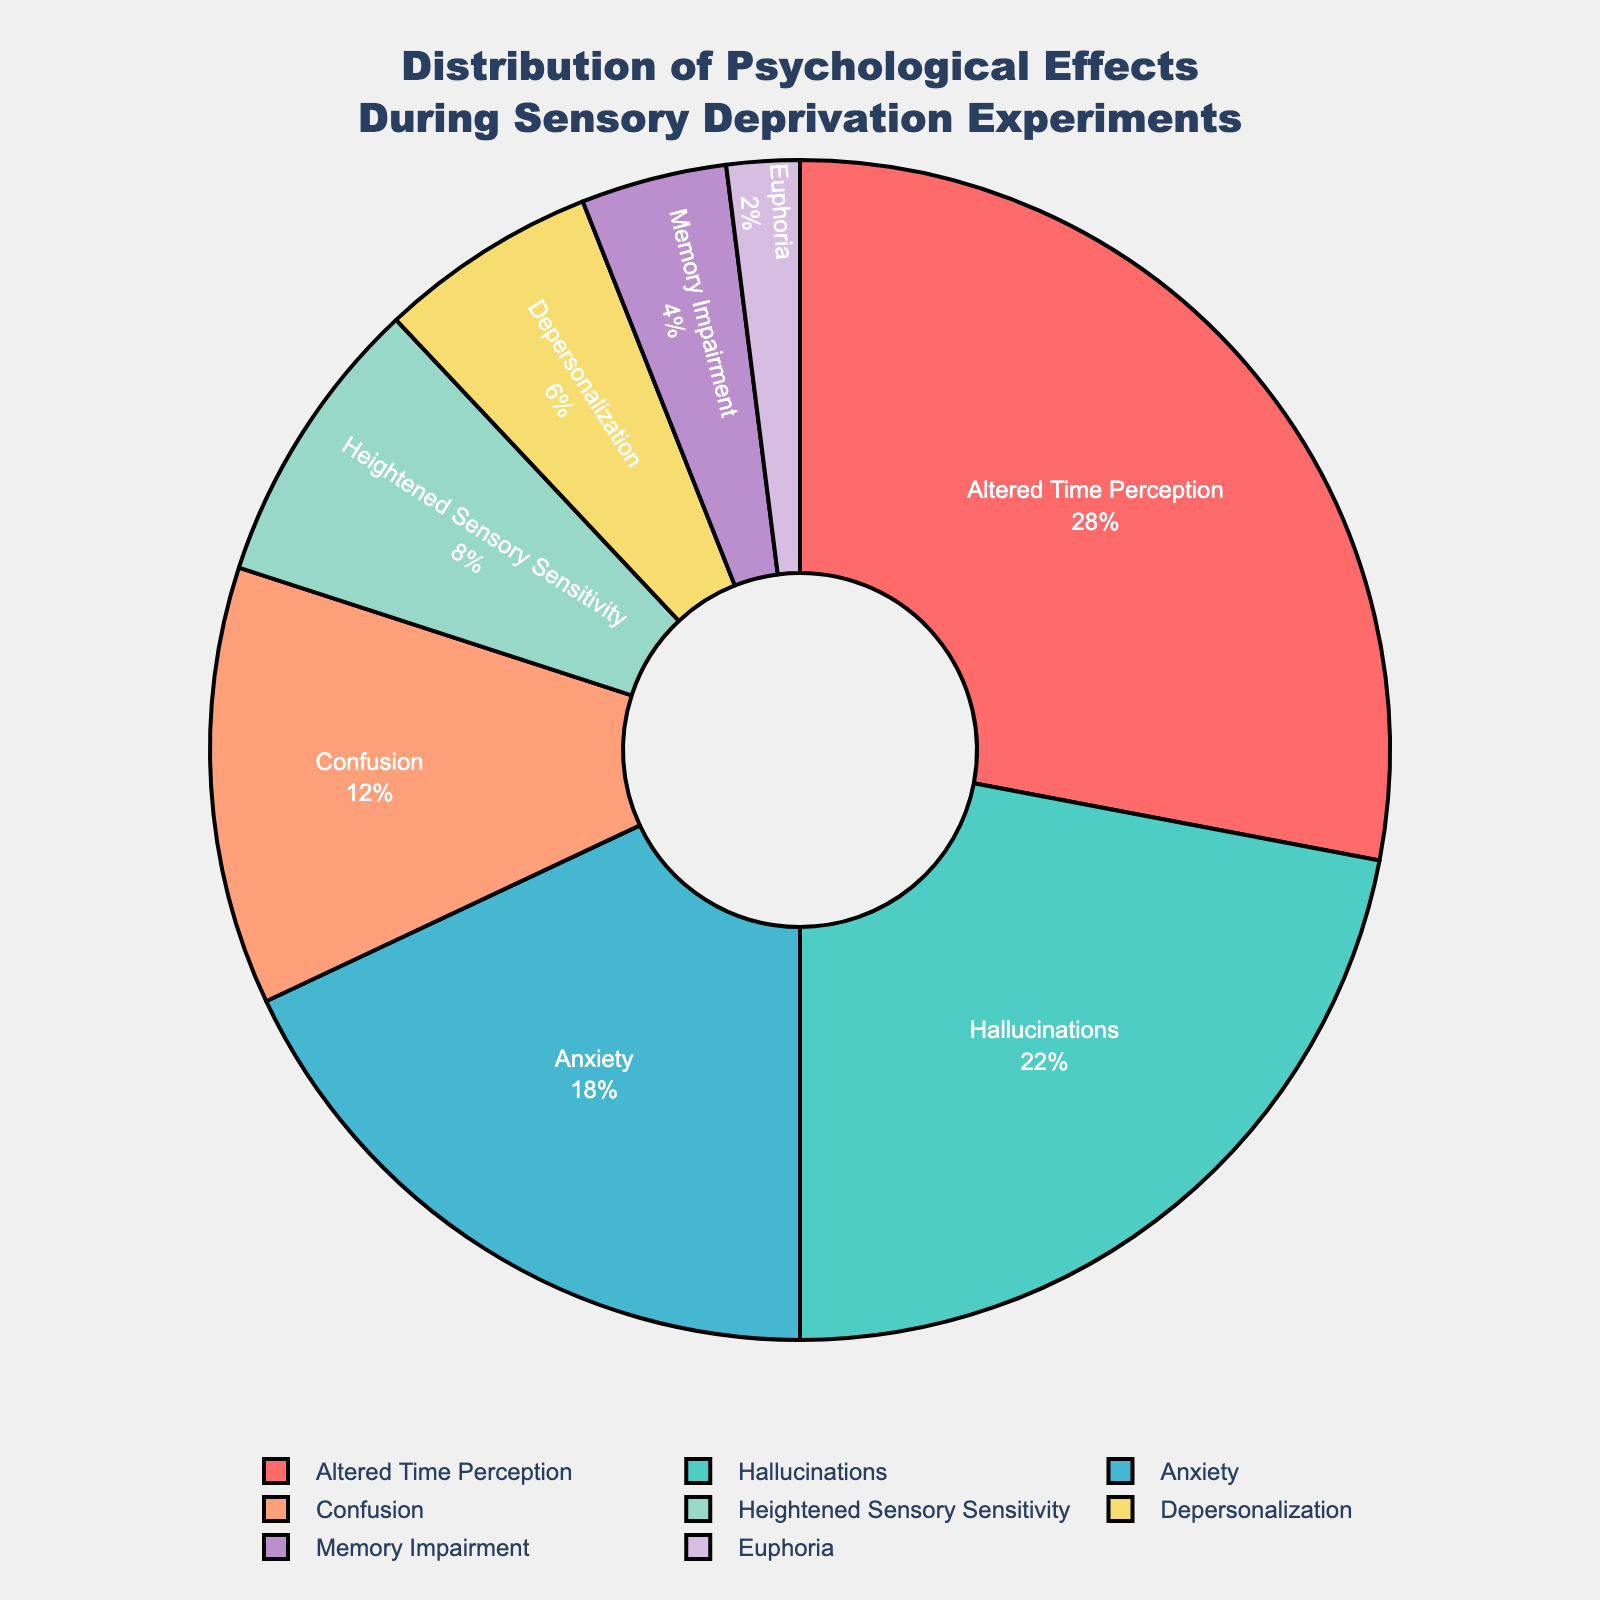Which psychological effect is reported the most during sensory deprivation experiments? The slice labeled "Altered Time Perception" occupies the largest portion of the pie chart, indicating it has the highest percentage.
Answer: Altered Time Perception Which two psychological effects together account for 50% of the total reports? The effects "Altered Time Perception" (28%) and "Hallucinations" (22%) when combined equal 28% + 22% = 50%.
Answer: Altered Time Perception and Hallucinations Which psychological effect is reported less frequently: Anxiety or Confusion? The slice for "Anxiety" occupies 18% while "Confusion" occupies 12%. Thus, "Confusion" is reported less frequently.
Answer: Confusion What percentage of reported effects are attributed to either Heightened Sensory Sensitivity or Depersonalization? "Heightened Sensory Sensitivity" is 8% and "Depersonalization" is 6%. Together, they account for 8% + 6% = 14%.
Answer: 14% How does the percentage of Memory Impairment compare to that of Euphoria? "Memory Impairment" is reported at 4% while "Euphoria" is at 2%. Therefore, "Memory Impairment" is reported twice as frequently as "Euphoria".
Answer: Memory Impairment is twice as frequent What is the combined percentage of psychological effects other than the three most frequent ones? The three most frequent effects are "Altered Time Perception" (28%), "Hallucinations" (22%), and "Anxiety" (18%), totaling 28% + 22% + 18% = 68%. So, the remaining effects account for 100% - 68% = 32%.
Answer: 32% Which three effects together make up less than 20% of the total and what are their individual percentages? The effects are "Depersonalization" (6%), "Memory Impairment" (4%), and "Euphoria" (2%). Together, these total 6% + 4% + 2% = 12%, which is less than 20%.
Answer: Depersonalization (6%), Memory Impairment (4%), and Euphoria (2%) What is the color used to represent Hallucinations, and how does it visually distinguish itself from Altered Time Perception? "Hallucinations" is represented by a turquoise slice, while "Altered Time Perception" is in red. The distinct colors help viewers quickly differentiate between the two effects.
Answer: Turquoise for Hallucinations and Red for Altered Time Perception Between Heightened Sensory Sensitivity and Euphoria, which effect is depicted with a larger slice, and by what margin? "Heightened Sensory Sensitivity" represents 8% and is larger than "Euphoria," which represents 2%. The margin is 8% - 2% = 6%.
Answer: Heightened Sensory Sensitivity by 6% Is the percentage of Confusion closer to that of Heightened Sensory Sensitivity or Depersonalization? "Confusion" is at 12%, "Heightened Sensory Sensitivity" is at 8% (difference of 4%), and "Depersonalization" is at 6% (difference of 6%). Therefore, it is closer to "Heightened Sensory Sensitivity".
Answer: Heightened Sensory Sensitivity 